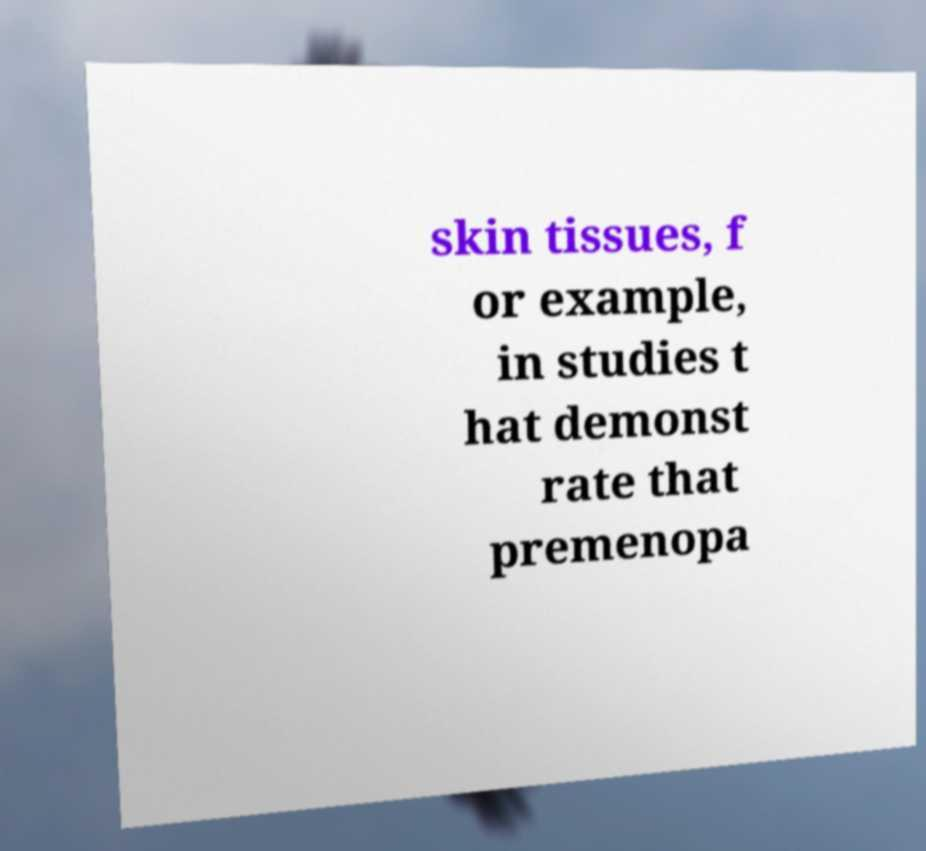Can you accurately transcribe the text from the provided image for me? skin tissues, f or example, in studies t hat demonst rate that premenopa 